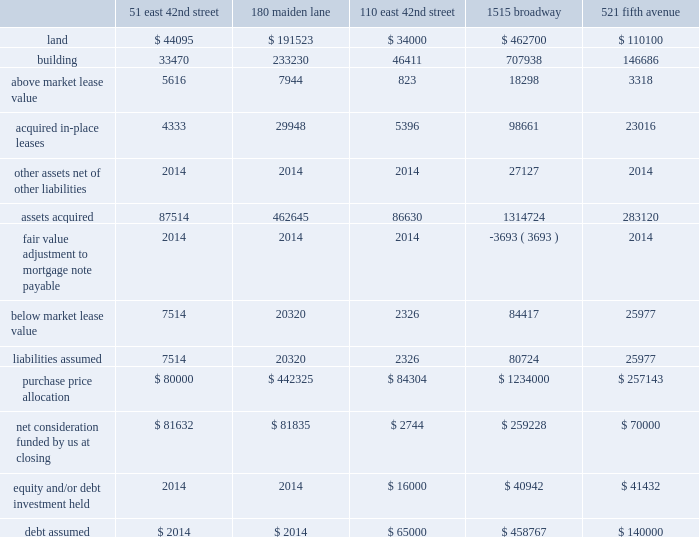Sl green realty corp .
It happens here 2012 annual report 85 | 85 in april a02011 , we purchased sitq immobilier , a subsid- iary of caisse de depot et placement du quebec , or sitq 2019s , 31.5% ( 31.5 % ) economic interest in 1515 a0 broadway , thereby consoli- dating full ownership of the 1750000 a0square foot ( unaudited ) building .
The transaction valued the consolidated interests at $ 1.23 a0 billion .
This valuation was based on a negotiated sales agreement and took into consideration such factors as whether this was a distressed sale and whether a minority dis- count was warranted .
We acquired the interest subject to the $ 458.8 a0million mortgage encumbering the property .
We rec- ognized a purchase price fair value adjustment of $ 475.1 a0mil- lion upon the closing of this transaction .
This property , which we initially acquired in may a02002 , was previously accounted for as an investment in unconsolidated joint ventures .
In january a0 2011 , we purchased city investment fund , or cif 2019s , 49.9% ( 49.9 % ) a0interest in 521 a0fifth avenue , thereby assum- ing full ownership of the 460000 a0 square foot ( unaudited ) building .
The transaction valued the consolidated interests at approximately $ 245.7 a0 million , excluding $ 4.5 a0 million of cash and other assets acquired .
We acquired the interest subject to the $ 140.0 a0 million mortgage encumbering the property .
We recognized a purchase price fair value adjust- ment of $ 13.8 a0million upon the closing of this transaction .
In april a02011 , we refinanced the property with a new $ 150.0 a0mil- lion 2-year mortgage which carries a floating rate of interest of 200 a0basis points over the 30-day libor .
In connection with that refinancing , we acquired the fee interest in the property for $ 15.0 a0million .
The following summarizes our allocation of the purchase price of the assets acquired and liabilities assumed upon the closing of these 2011 acquisitions ( amounts in thousands ) : 51 east 180 110 east 1515 521 fifth 42nd street maiden lane 42nd street broadway avenue land fffd$ 44095 $ 191523 $ 34000 $ 2002 2008462700 $ 110100 .
Net consideration funded by us at closing fffd$ 81632 $ 200281835 $ 20022744 $ 2002 2008259228 $ 200270000 equity and/or debt investment held fffd 2014 2014 $ 16000 $ 2002 2002 200840942 $ 200241432 debt assumed fffd$ 2002 2002 2002 2002 2008 2014 $ 2002 2002 2002 2002 2002 2008 2014 $ 65000 $ 2002 2008458767 $ 140000 2010 acquisitions | in january 2010 , we became the sole owner of 100 a0church street , a 1.05 a0million square foot ( unau- dited ) office tower located in downtown manhattan , following the successful foreclosure of the senior mezzanine loan at the property .
Our initial investment totaled $ 40.9 a0million , which was comprised of a 50% ( 50 % ) a0interest in the senior mezzanine loan and two other mezzanine loans at 100 a0 church street , which we acquired from gramercy capital corp .
( nyse : a0gkk ) , or gramercy , in the summer of a0 2007 .
At closing of the foreclo- sure , we funded an additional $ 15.0 a0million of capital into the project as part of our agreement with wachovia bank , n.a .
To extend and restructure the existing financing .
Gramercy declined to fund its share of this capital and instead trans- ferred its interests in the investment to us at closing .
The restructured $ 139.7 a0million mortgage carries an interest rate of 350 a0basis points over the 30-day libor .
The restructured mortgage , which was scheduled to mature in january a0 2013 , was repaid in march a02011 .
In august a0 2010 , we acquired 125 a0 park avenue , a manhattan office tower , for $ 330 a0million .
In connection with the acquisition , we assumed $ 146.25 a0million of in-place financ- ing .
The 5.748% ( 5.748 % ) interest-only loan matures in october a02014 .
In december a02010 , we completed the acquisition of various investments from gramercy .
This acquisition included ( 1 ) a0the remaining 45% ( 45 % ) a0interest in the leased fee at 885 a0third avenue for approximately $ 39.3 a0 million plus assumed mortgage debt of approximately $ 120.4 a0million , ( 2 ) a0the remaining 45% ( 45 % ) interest in the leased fee at 2 a0 herald square for approxi- mately $ 25.6 a0 million plus assumed mortgage debt of approximately $ 86.1 a0 million and , ( 3 ) a0 the entire leased fee interest in 292 a0madison avenue for approximately $ 19.2 a0mil- lion plus assumed mortgage debt of approximately $ 59.1 a0million .
These assets are all leased to third a0party operators. .
What was the company's share of the value of the 521 fifth avenue acquisition based on the transaction cost? 
Computations: ((245.7 * 49.9%) * 1000000)
Answer: 122604300.0. Sl green realty corp .
It happens here 2012 annual report 85 | 85 in april a02011 , we purchased sitq immobilier , a subsid- iary of caisse de depot et placement du quebec , or sitq 2019s , 31.5% ( 31.5 % ) economic interest in 1515 a0 broadway , thereby consoli- dating full ownership of the 1750000 a0square foot ( unaudited ) building .
The transaction valued the consolidated interests at $ 1.23 a0 billion .
This valuation was based on a negotiated sales agreement and took into consideration such factors as whether this was a distressed sale and whether a minority dis- count was warranted .
We acquired the interest subject to the $ 458.8 a0million mortgage encumbering the property .
We rec- ognized a purchase price fair value adjustment of $ 475.1 a0mil- lion upon the closing of this transaction .
This property , which we initially acquired in may a02002 , was previously accounted for as an investment in unconsolidated joint ventures .
In january a0 2011 , we purchased city investment fund , or cif 2019s , 49.9% ( 49.9 % ) a0interest in 521 a0fifth avenue , thereby assum- ing full ownership of the 460000 a0 square foot ( unaudited ) building .
The transaction valued the consolidated interests at approximately $ 245.7 a0 million , excluding $ 4.5 a0 million of cash and other assets acquired .
We acquired the interest subject to the $ 140.0 a0 million mortgage encumbering the property .
We recognized a purchase price fair value adjust- ment of $ 13.8 a0million upon the closing of this transaction .
In april a02011 , we refinanced the property with a new $ 150.0 a0mil- lion 2-year mortgage which carries a floating rate of interest of 200 a0basis points over the 30-day libor .
In connection with that refinancing , we acquired the fee interest in the property for $ 15.0 a0million .
The following summarizes our allocation of the purchase price of the assets acquired and liabilities assumed upon the closing of these 2011 acquisitions ( amounts in thousands ) : 51 east 180 110 east 1515 521 fifth 42nd street maiden lane 42nd street broadway avenue land fffd$ 44095 $ 191523 $ 34000 $ 2002 2008462700 $ 110100 .
Net consideration funded by us at closing fffd$ 81632 $ 200281835 $ 20022744 $ 2002 2008259228 $ 200270000 equity and/or debt investment held fffd 2014 2014 $ 16000 $ 2002 2002 200840942 $ 200241432 debt assumed fffd$ 2002 2002 2002 2002 2008 2014 $ 2002 2002 2002 2002 2002 2008 2014 $ 65000 $ 2002 2008458767 $ 140000 2010 acquisitions | in january 2010 , we became the sole owner of 100 a0church street , a 1.05 a0million square foot ( unau- dited ) office tower located in downtown manhattan , following the successful foreclosure of the senior mezzanine loan at the property .
Our initial investment totaled $ 40.9 a0million , which was comprised of a 50% ( 50 % ) a0interest in the senior mezzanine loan and two other mezzanine loans at 100 a0 church street , which we acquired from gramercy capital corp .
( nyse : a0gkk ) , or gramercy , in the summer of a0 2007 .
At closing of the foreclo- sure , we funded an additional $ 15.0 a0million of capital into the project as part of our agreement with wachovia bank , n.a .
To extend and restructure the existing financing .
Gramercy declined to fund its share of this capital and instead trans- ferred its interests in the investment to us at closing .
The restructured $ 139.7 a0million mortgage carries an interest rate of 350 a0basis points over the 30-day libor .
The restructured mortgage , which was scheduled to mature in january a0 2013 , was repaid in march a02011 .
In august a0 2010 , we acquired 125 a0 park avenue , a manhattan office tower , for $ 330 a0million .
In connection with the acquisition , we assumed $ 146.25 a0million of in-place financ- ing .
The 5.748% ( 5.748 % ) interest-only loan matures in october a02014 .
In december a02010 , we completed the acquisition of various investments from gramercy .
This acquisition included ( 1 ) a0the remaining 45% ( 45 % ) a0interest in the leased fee at 885 a0third avenue for approximately $ 39.3 a0 million plus assumed mortgage debt of approximately $ 120.4 a0million , ( 2 ) a0the remaining 45% ( 45 % ) interest in the leased fee at 2 a0 herald square for approxi- mately $ 25.6 a0 million plus assumed mortgage debt of approximately $ 86.1 a0 million and , ( 3 ) a0 the entire leased fee interest in 292 a0madison avenue for approximately $ 19.2 a0mil- lion plus assumed mortgage debt of approximately $ 59.1 a0million .
These assets are all leased to third a0party operators. .
What is the annual interest cost in millions for the 125 park avenue acquisition? 
Computations: (146.25 * 5.748%)
Answer: 8.40645. 